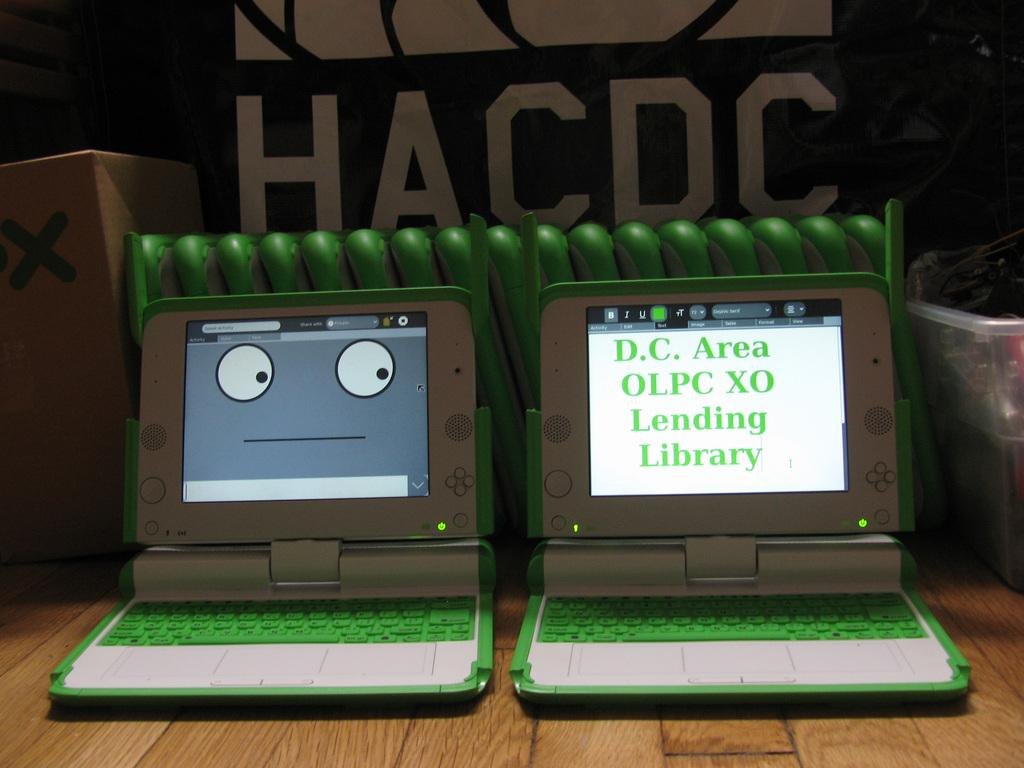What electronic devices are visible on the wooden surface in the image? There are laptops with screens on a wooden surface in the image. What type of container is present in the image? There is a container in the image. What additional object can be seen in the image? There is a cardboard box in the image. What type of bean is being cooked in the container in the image? There is no bean or cooking activity present in the image. Can you tell me the name of the father in the image? There are no people or family members present in the image. 